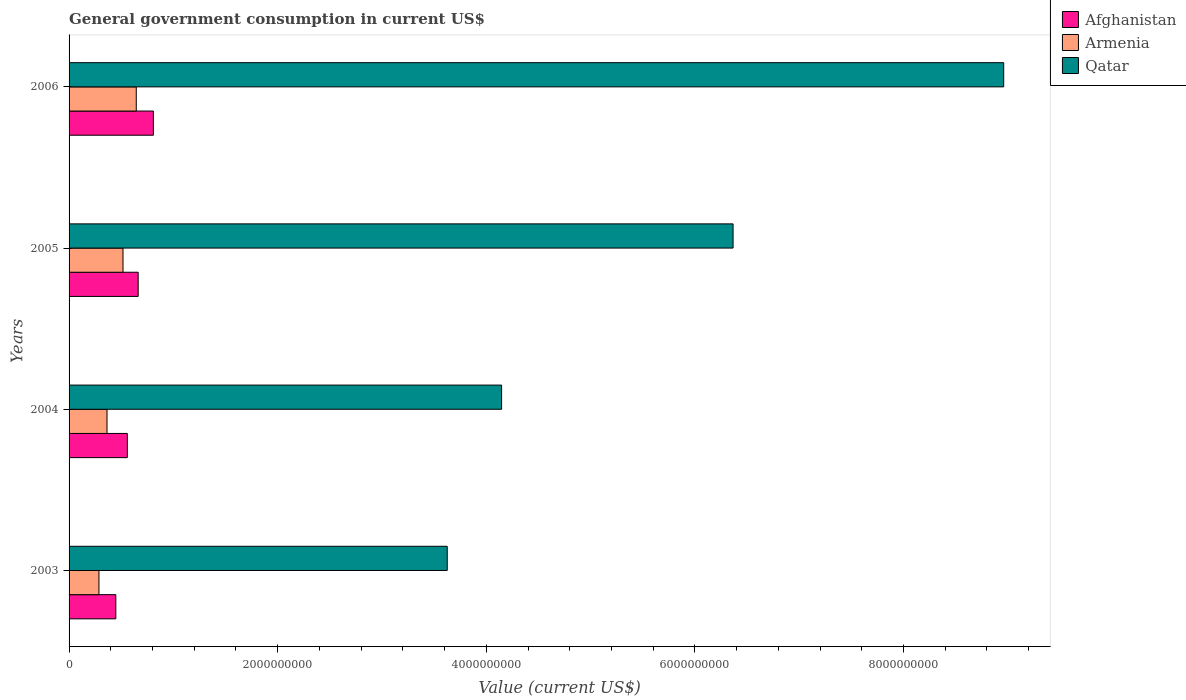How many groups of bars are there?
Make the answer very short. 4. How many bars are there on the 3rd tick from the top?
Ensure brevity in your answer.  3. How many bars are there on the 2nd tick from the bottom?
Your answer should be very brief. 3. What is the label of the 3rd group of bars from the top?
Your answer should be compact. 2004. In how many cases, is the number of bars for a given year not equal to the number of legend labels?
Give a very brief answer. 0. What is the government conusmption in Armenia in 2006?
Ensure brevity in your answer.  6.44e+08. Across all years, what is the maximum government conusmption in Armenia?
Make the answer very short. 6.44e+08. Across all years, what is the minimum government conusmption in Qatar?
Provide a succinct answer. 3.63e+09. What is the total government conusmption in Armenia in the graph?
Your response must be concise. 1.81e+09. What is the difference between the government conusmption in Armenia in 2004 and that in 2006?
Your response must be concise. -2.80e+08. What is the difference between the government conusmption in Armenia in 2004 and the government conusmption in Afghanistan in 2006?
Give a very brief answer. -4.44e+08. What is the average government conusmption in Qatar per year?
Give a very brief answer. 5.77e+09. In the year 2006, what is the difference between the government conusmption in Afghanistan and government conusmption in Armenia?
Your answer should be compact. 1.64e+08. In how many years, is the government conusmption in Armenia greater than 4800000000 US$?
Provide a succinct answer. 0. What is the ratio of the government conusmption in Armenia in 2003 to that in 2005?
Your response must be concise. 0.55. Is the government conusmption in Afghanistan in 2003 less than that in 2006?
Give a very brief answer. Yes. What is the difference between the highest and the second highest government conusmption in Afghanistan?
Ensure brevity in your answer.  1.46e+08. What is the difference between the highest and the lowest government conusmption in Afghanistan?
Make the answer very short. 3.60e+08. In how many years, is the government conusmption in Armenia greater than the average government conusmption in Armenia taken over all years?
Make the answer very short. 2. What does the 3rd bar from the top in 2003 represents?
Give a very brief answer. Afghanistan. What does the 3rd bar from the bottom in 2004 represents?
Offer a very short reply. Qatar. Is it the case that in every year, the sum of the government conusmption in Qatar and government conusmption in Armenia is greater than the government conusmption in Afghanistan?
Your response must be concise. Yes. How many bars are there?
Your answer should be very brief. 12. What is the difference between two consecutive major ticks on the X-axis?
Provide a short and direct response. 2.00e+09. Does the graph contain grids?
Give a very brief answer. No. How are the legend labels stacked?
Make the answer very short. Vertical. What is the title of the graph?
Provide a short and direct response. General government consumption in current US$. Does "Bahrain" appear as one of the legend labels in the graph?
Your answer should be very brief. No. What is the label or title of the X-axis?
Provide a succinct answer. Value (current US$). What is the label or title of the Y-axis?
Make the answer very short. Years. What is the Value (current US$) in Afghanistan in 2003?
Provide a short and direct response. 4.48e+08. What is the Value (current US$) in Armenia in 2003?
Keep it short and to the point. 2.87e+08. What is the Value (current US$) of Qatar in 2003?
Ensure brevity in your answer.  3.63e+09. What is the Value (current US$) in Afghanistan in 2004?
Offer a terse response. 5.59e+08. What is the Value (current US$) of Armenia in 2004?
Your response must be concise. 3.64e+08. What is the Value (current US$) in Qatar in 2004?
Offer a very short reply. 4.15e+09. What is the Value (current US$) of Afghanistan in 2005?
Offer a very short reply. 6.63e+08. What is the Value (current US$) in Armenia in 2005?
Make the answer very short. 5.17e+08. What is the Value (current US$) in Qatar in 2005?
Your response must be concise. 6.37e+09. What is the Value (current US$) of Afghanistan in 2006?
Offer a terse response. 8.08e+08. What is the Value (current US$) in Armenia in 2006?
Ensure brevity in your answer.  6.44e+08. What is the Value (current US$) of Qatar in 2006?
Provide a succinct answer. 8.96e+09. Across all years, what is the maximum Value (current US$) of Afghanistan?
Keep it short and to the point. 8.08e+08. Across all years, what is the maximum Value (current US$) of Armenia?
Your answer should be compact. 6.44e+08. Across all years, what is the maximum Value (current US$) of Qatar?
Your answer should be very brief. 8.96e+09. Across all years, what is the minimum Value (current US$) of Afghanistan?
Your response must be concise. 4.48e+08. Across all years, what is the minimum Value (current US$) in Armenia?
Offer a very short reply. 2.87e+08. Across all years, what is the minimum Value (current US$) of Qatar?
Offer a terse response. 3.63e+09. What is the total Value (current US$) of Afghanistan in the graph?
Your answer should be compact. 2.48e+09. What is the total Value (current US$) of Armenia in the graph?
Your response must be concise. 1.81e+09. What is the total Value (current US$) of Qatar in the graph?
Provide a succinct answer. 2.31e+1. What is the difference between the Value (current US$) of Afghanistan in 2003 and that in 2004?
Give a very brief answer. -1.10e+08. What is the difference between the Value (current US$) of Armenia in 2003 and that in 2004?
Keep it short and to the point. -7.73e+07. What is the difference between the Value (current US$) of Qatar in 2003 and that in 2004?
Provide a short and direct response. -5.21e+08. What is the difference between the Value (current US$) of Afghanistan in 2003 and that in 2005?
Provide a short and direct response. -2.14e+08. What is the difference between the Value (current US$) of Armenia in 2003 and that in 2005?
Your response must be concise. -2.31e+08. What is the difference between the Value (current US$) of Qatar in 2003 and that in 2005?
Make the answer very short. -2.74e+09. What is the difference between the Value (current US$) in Afghanistan in 2003 and that in 2006?
Ensure brevity in your answer.  -3.60e+08. What is the difference between the Value (current US$) in Armenia in 2003 and that in 2006?
Provide a short and direct response. -3.58e+08. What is the difference between the Value (current US$) of Qatar in 2003 and that in 2006?
Keep it short and to the point. -5.33e+09. What is the difference between the Value (current US$) of Afghanistan in 2004 and that in 2005?
Make the answer very short. -1.04e+08. What is the difference between the Value (current US$) in Armenia in 2004 and that in 2005?
Offer a very short reply. -1.53e+08. What is the difference between the Value (current US$) in Qatar in 2004 and that in 2005?
Make the answer very short. -2.22e+09. What is the difference between the Value (current US$) in Afghanistan in 2004 and that in 2006?
Make the answer very short. -2.50e+08. What is the difference between the Value (current US$) of Armenia in 2004 and that in 2006?
Give a very brief answer. -2.80e+08. What is the difference between the Value (current US$) of Qatar in 2004 and that in 2006?
Keep it short and to the point. -4.81e+09. What is the difference between the Value (current US$) in Afghanistan in 2005 and that in 2006?
Your answer should be compact. -1.46e+08. What is the difference between the Value (current US$) in Armenia in 2005 and that in 2006?
Give a very brief answer. -1.27e+08. What is the difference between the Value (current US$) of Qatar in 2005 and that in 2006?
Your response must be concise. -2.59e+09. What is the difference between the Value (current US$) in Afghanistan in 2003 and the Value (current US$) in Armenia in 2004?
Provide a succinct answer. 8.44e+07. What is the difference between the Value (current US$) of Afghanistan in 2003 and the Value (current US$) of Qatar in 2004?
Give a very brief answer. -3.70e+09. What is the difference between the Value (current US$) of Armenia in 2003 and the Value (current US$) of Qatar in 2004?
Ensure brevity in your answer.  -3.86e+09. What is the difference between the Value (current US$) in Afghanistan in 2003 and the Value (current US$) in Armenia in 2005?
Your answer should be very brief. -6.88e+07. What is the difference between the Value (current US$) of Afghanistan in 2003 and the Value (current US$) of Qatar in 2005?
Offer a very short reply. -5.92e+09. What is the difference between the Value (current US$) of Armenia in 2003 and the Value (current US$) of Qatar in 2005?
Offer a terse response. -6.08e+09. What is the difference between the Value (current US$) of Afghanistan in 2003 and the Value (current US$) of Armenia in 2006?
Your answer should be very brief. -1.96e+08. What is the difference between the Value (current US$) in Afghanistan in 2003 and the Value (current US$) in Qatar in 2006?
Keep it short and to the point. -8.51e+09. What is the difference between the Value (current US$) in Armenia in 2003 and the Value (current US$) in Qatar in 2006?
Offer a terse response. -8.67e+09. What is the difference between the Value (current US$) in Afghanistan in 2004 and the Value (current US$) in Armenia in 2005?
Keep it short and to the point. 4.17e+07. What is the difference between the Value (current US$) of Afghanistan in 2004 and the Value (current US$) of Qatar in 2005?
Keep it short and to the point. -5.81e+09. What is the difference between the Value (current US$) in Armenia in 2004 and the Value (current US$) in Qatar in 2005?
Your response must be concise. -6.00e+09. What is the difference between the Value (current US$) of Afghanistan in 2004 and the Value (current US$) of Armenia in 2006?
Your answer should be compact. -8.55e+07. What is the difference between the Value (current US$) of Afghanistan in 2004 and the Value (current US$) of Qatar in 2006?
Provide a short and direct response. -8.40e+09. What is the difference between the Value (current US$) in Armenia in 2004 and the Value (current US$) in Qatar in 2006?
Your answer should be compact. -8.60e+09. What is the difference between the Value (current US$) of Afghanistan in 2005 and the Value (current US$) of Armenia in 2006?
Your answer should be very brief. 1.83e+07. What is the difference between the Value (current US$) in Afghanistan in 2005 and the Value (current US$) in Qatar in 2006?
Give a very brief answer. -8.30e+09. What is the difference between the Value (current US$) of Armenia in 2005 and the Value (current US$) of Qatar in 2006?
Give a very brief answer. -8.44e+09. What is the average Value (current US$) in Afghanistan per year?
Your answer should be very brief. 6.19e+08. What is the average Value (current US$) of Armenia per year?
Your answer should be very brief. 4.53e+08. What is the average Value (current US$) of Qatar per year?
Make the answer very short. 5.77e+09. In the year 2003, what is the difference between the Value (current US$) of Afghanistan and Value (current US$) of Armenia?
Provide a succinct answer. 1.62e+08. In the year 2003, what is the difference between the Value (current US$) in Afghanistan and Value (current US$) in Qatar?
Your answer should be compact. -3.18e+09. In the year 2003, what is the difference between the Value (current US$) in Armenia and Value (current US$) in Qatar?
Your response must be concise. -3.34e+09. In the year 2004, what is the difference between the Value (current US$) in Afghanistan and Value (current US$) in Armenia?
Provide a succinct answer. 1.95e+08. In the year 2004, what is the difference between the Value (current US$) of Afghanistan and Value (current US$) of Qatar?
Your answer should be compact. -3.59e+09. In the year 2004, what is the difference between the Value (current US$) of Armenia and Value (current US$) of Qatar?
Your answer should be very brief. -3.78e+09. In the year 2005, what is the difference between the Value (current US$) of Afghanistan and Value (current US$) of Armenia?
Provide a short and direct response. 1.45e+08. In the year 2005, what is the difference between the Value (current US$) of Afghanistan and Value (current US$) of Qatar?
Offer a very short reply. -5.70e+09. In the year 2005, what is the difference between the Value (current US$) in Armenia and Value (current US$) in Qatar?
Offer a very short reply. -5.85e+09. In the year 2006, what is the difference between the Value (current US$) of Afghanistan and Value (current US$) of Armenia?
Your answer should be very brief. 1.64e+08. In the year 2006, what is the difference between the Value (current US$) in Afghanistan and Value (current US$) in Qatar?
Your answer should be compact. -8.15e+09. In the year 2006, what is the difference between the Value (current US$) in Armenia and Value (current US$) in Qatar?
Give a very brief answer. -8.32e+09. What is the ratio of the Value (current US$) in Afghanistan in 2003 to that in 2004?
Ensure brevity in your answer.  0.8. What is the ratio of the Value (current US$) in Armenia in 2003 to that in 2004?
Offer a very short reply. 0.79. What is the ratio of the Value (current US$) in Qatar in 2003 to that in 2004?
Make the answer very short. 0.87. What is the ratio of the Value (current US$) in Afghanistan in 2003 to that in 2005?
Your response must be concise. 0.68. What is the ratio of the Value (current US$) of Armenia in 2003 to that in 2005?
Your response must be concise. 0.55. What is the ratio of the Value (current US$) in Qatar in 2003 to that in 2005?
Your answer should be very brief. 0.57. What is the ratio of the Value (current US$) of Afghanistan in 2003 to that in 2006?
Provide a succinct answer. 0.55. What is the ratio of the Value (current US$) of Armenia in 2003 to that in 2006?
Your answer should be compact. 0.44. What is the ratio of the Value (current US$) of Qatar in 2003 to that in 2006?
Provide a short and direct response. 0.4. What is the ratio of the Value (current US$) of Afghanistan in 2004 to that in 2005?
Provide a short and direct response. 0.84. What is the ratio of the Value (current US$) in Armenia in 2004 to that in 2005?
Offer a very short reply. 0.7. What is the ratio of the Value (current US$) in Qatar in 2004 to that in 2005?
Ensure brevity in your answer.  0.65. What is the ratio of the Value (current US$) in Afghanistan in 2004 to that in 2006?
Your answer should be compact. 0.69. What is the ratio of the Value (current US$) in Armenia in 2004 to that in 2006?
Your answer should be compact. 0.56. What is the ratio of the Value (current US$) in Qatar in 2004 to that in 2006?
Provide a succinct answer. 0.46. What is the ratio of the Value (current US$) of Afghanistan in 2005 to that in 2006?
Give a very brief answer. 0.82. What is the ratio of the Value (current US$) of Armenia in 2005 to that in 2006?
Offer a very short reply. 0.8. What is the ratio of the Value (current US$) of Qatar in 2005 to that in 2006?
Your response must be concise. 0.71. What is the difference between the highest and the second highest Value (current US$) of Afghanistan?
Keep it short and to the point. 1.46e+08. What is the difference between the highest and the second highest Value (current US$) in Armenia?
Your answer should be compact. 1.27e+08. What is the difference between the highest and the second highest Value (current US$) in Qatar?
Make the answer very short. 2.59e+09. What is the difference between the highest and the lowest Value (current US$) of Afghanistan?
Your answer should be compact. 3.60e+08. What is the difference between the highest and the lowest Value (current US$) of Armenia?
Your answer should be compact. 3.58e+08. What is the difference between the highest and the lowest Value (current US$) of Qatar?
Give a very brief answer. 5.33e+09. 